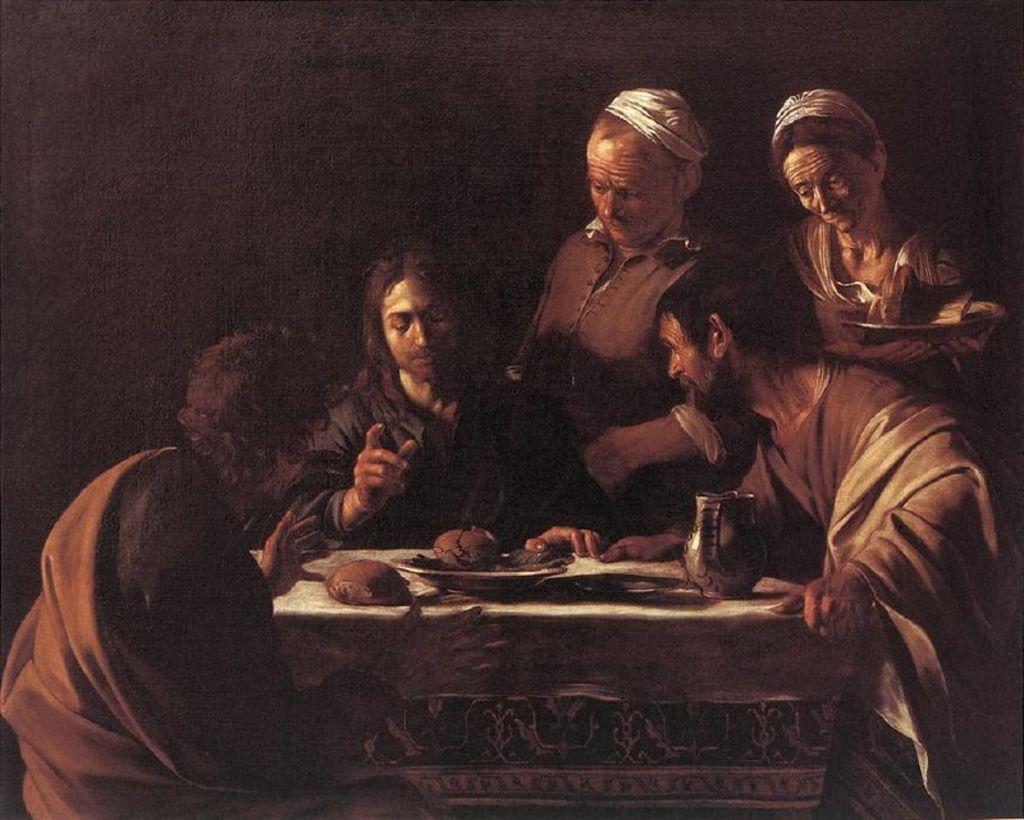Describe this image in one or two sentences. 3 Persons are sitting around the dining table and talking, on the right side 2 persons are standing. It's a painting. 